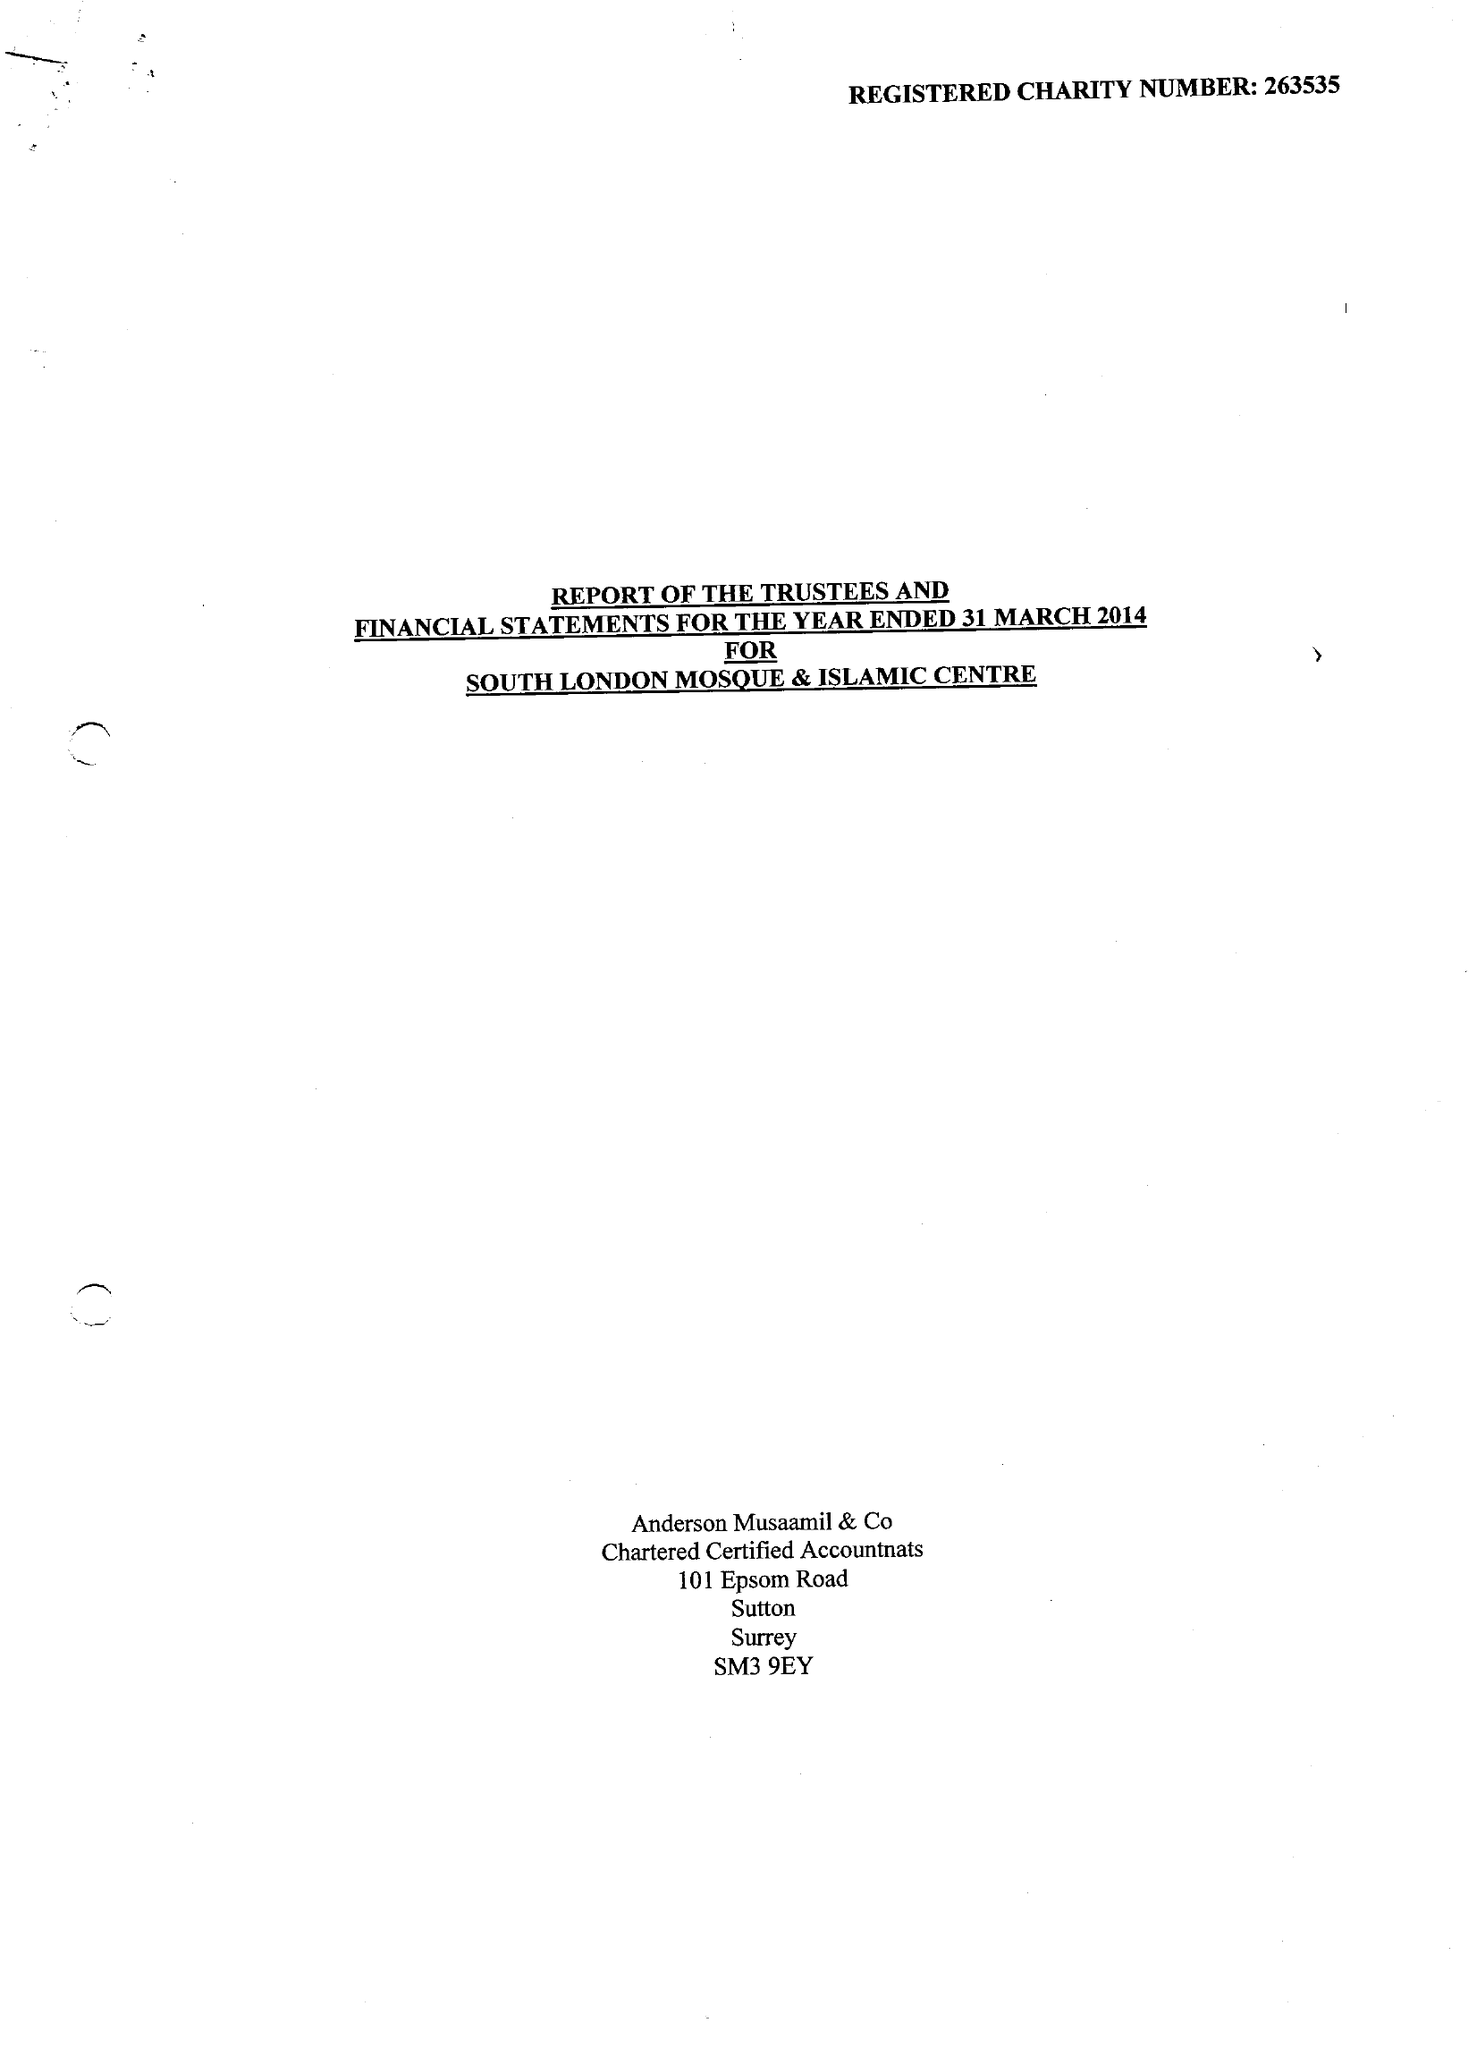What is the value for the address__street_line?
Answer the question using a single word or phrase. 8 MITCHAM LANE 